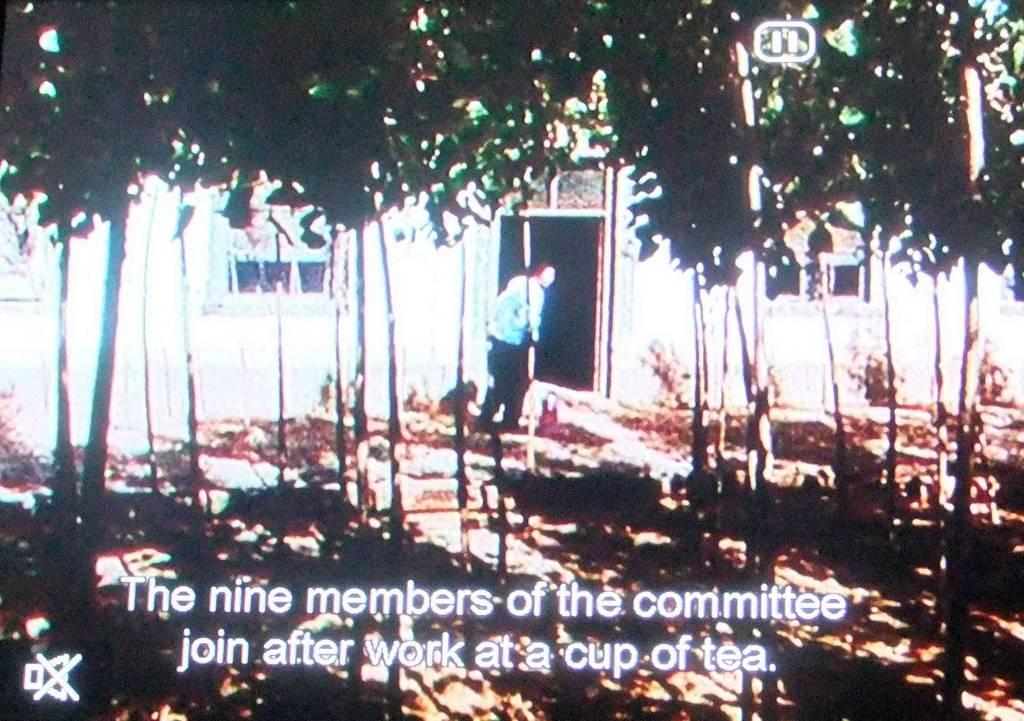Who is present in the image? There is a woman in the image. What is the woman's location in relation to the building? The woman is standing near a building. Can you describe the woman's proximity to a door? The woman is standing near a door. What type of vegetation can be seen at the top of the image? There are trees visible at the top of the image. What is present at the bottom of the image? There is a watermark at the bottom of the image. What type of playground equipment can be seen in the image? There is no playground equipment present in the image. What is the woman's desire in the image? The image does not provide information about the woman's desires or intentions. How many legs does the woman have in the image? The image does not show the woman's legs, so it is impossible to determine the number of legs she has. 